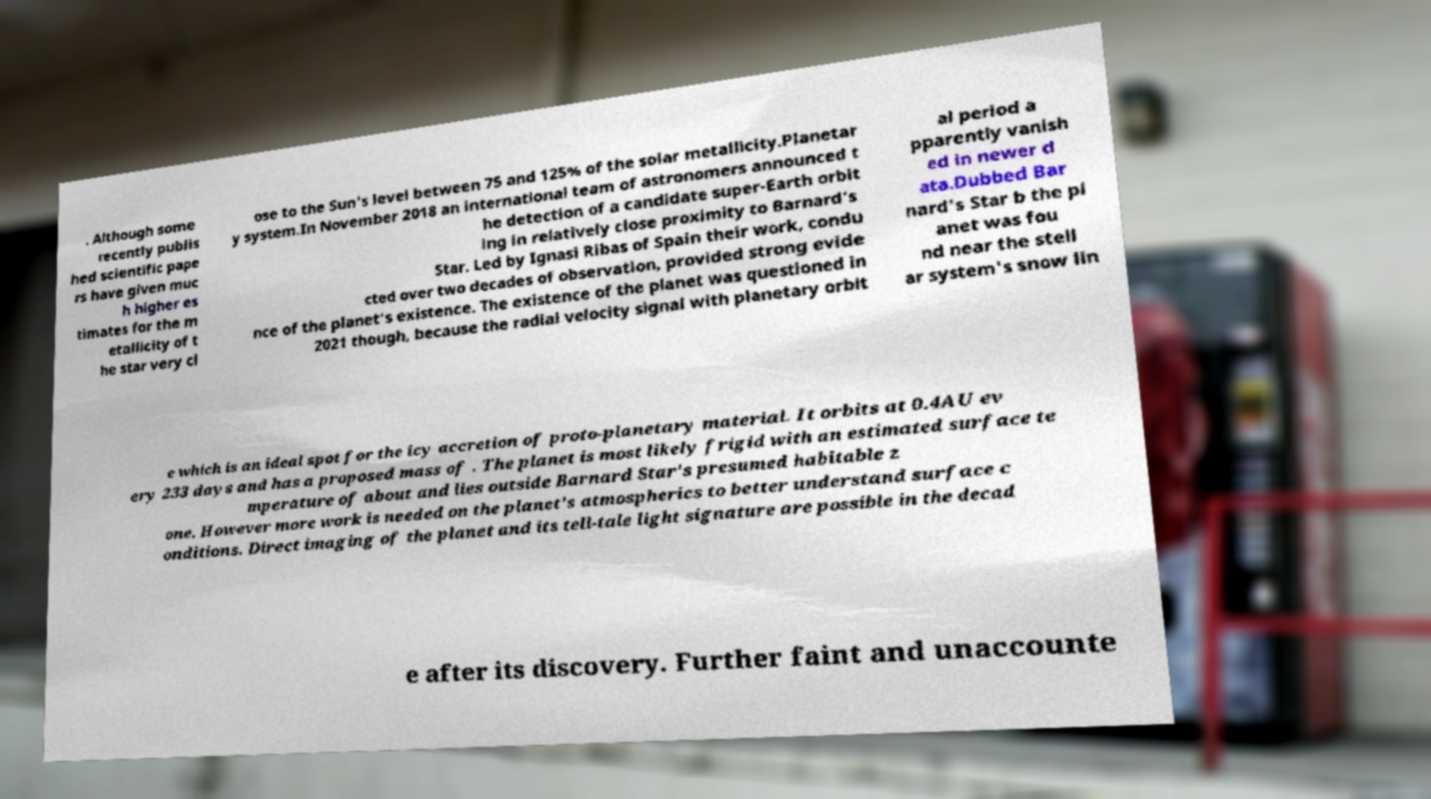Can you read and provide the text displayed in the image?This photo seems to have some interesting text. Can you extract and type it out for me? . Although some recently publis hed scientific pape rs have given muc h higher es timates for the m etallicity of t he star very cl ose to the Sun's level between 75 and 125% of the solar metallicity.Planetar y system.In November 2018 an international team of astronomers announced t he detection of a candidate super-Earth orbit ing in relatively close proximity to Barnard's Star. Led by Ignasi Ribas of Spain their work, condu cted over two decades of observation, provided strong evide nce of the planet's existence. The existence of the planet was questioned in 2021 though, because the radial velocity signal with planetary orbit al period a pparently vanish ed in newer d ata.Dubbed Bar nard's Star b the pl anet was fou nd near the stell ar system's snow lin e which is an ideal spot for the icy accretion of proto-planetary material. It orbits at 0.4AU ev ery 233 days and has a proposed mass of . The planet is most likely frigid with an estimated surface te mperature of about and lies outside Barnard Star's presumed habitable z one. However more work is needed on the planet's atmospherics to better understand surface c onditions. Direct imaging of the planet and its tell-tale light signature are possible in the decad e after its discovery. Further faint and unaccounte 